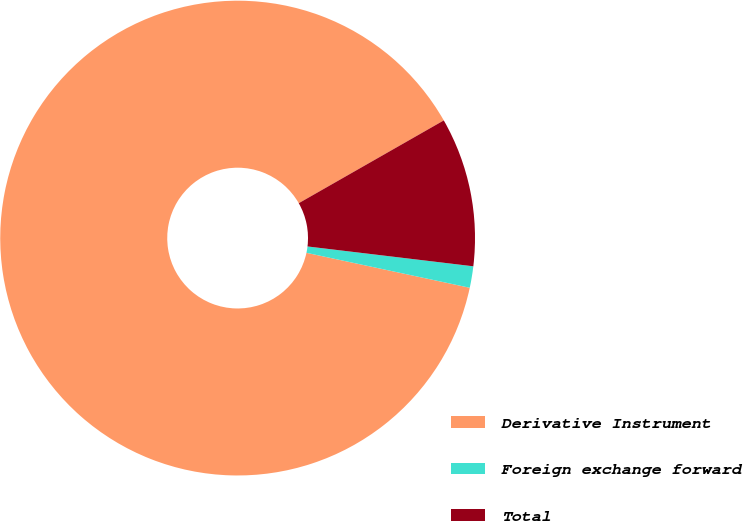Convert chart to OTSL. <chart><loc_0><loc_0><loc_500><loc_500><pie_chart><fcel>Derivative Instrument<fcel>Foreign exchange forward<fcel>Total<nl><fcel>88.39%<fcel>1.46%<fcel>10.15%<nl></chart> 